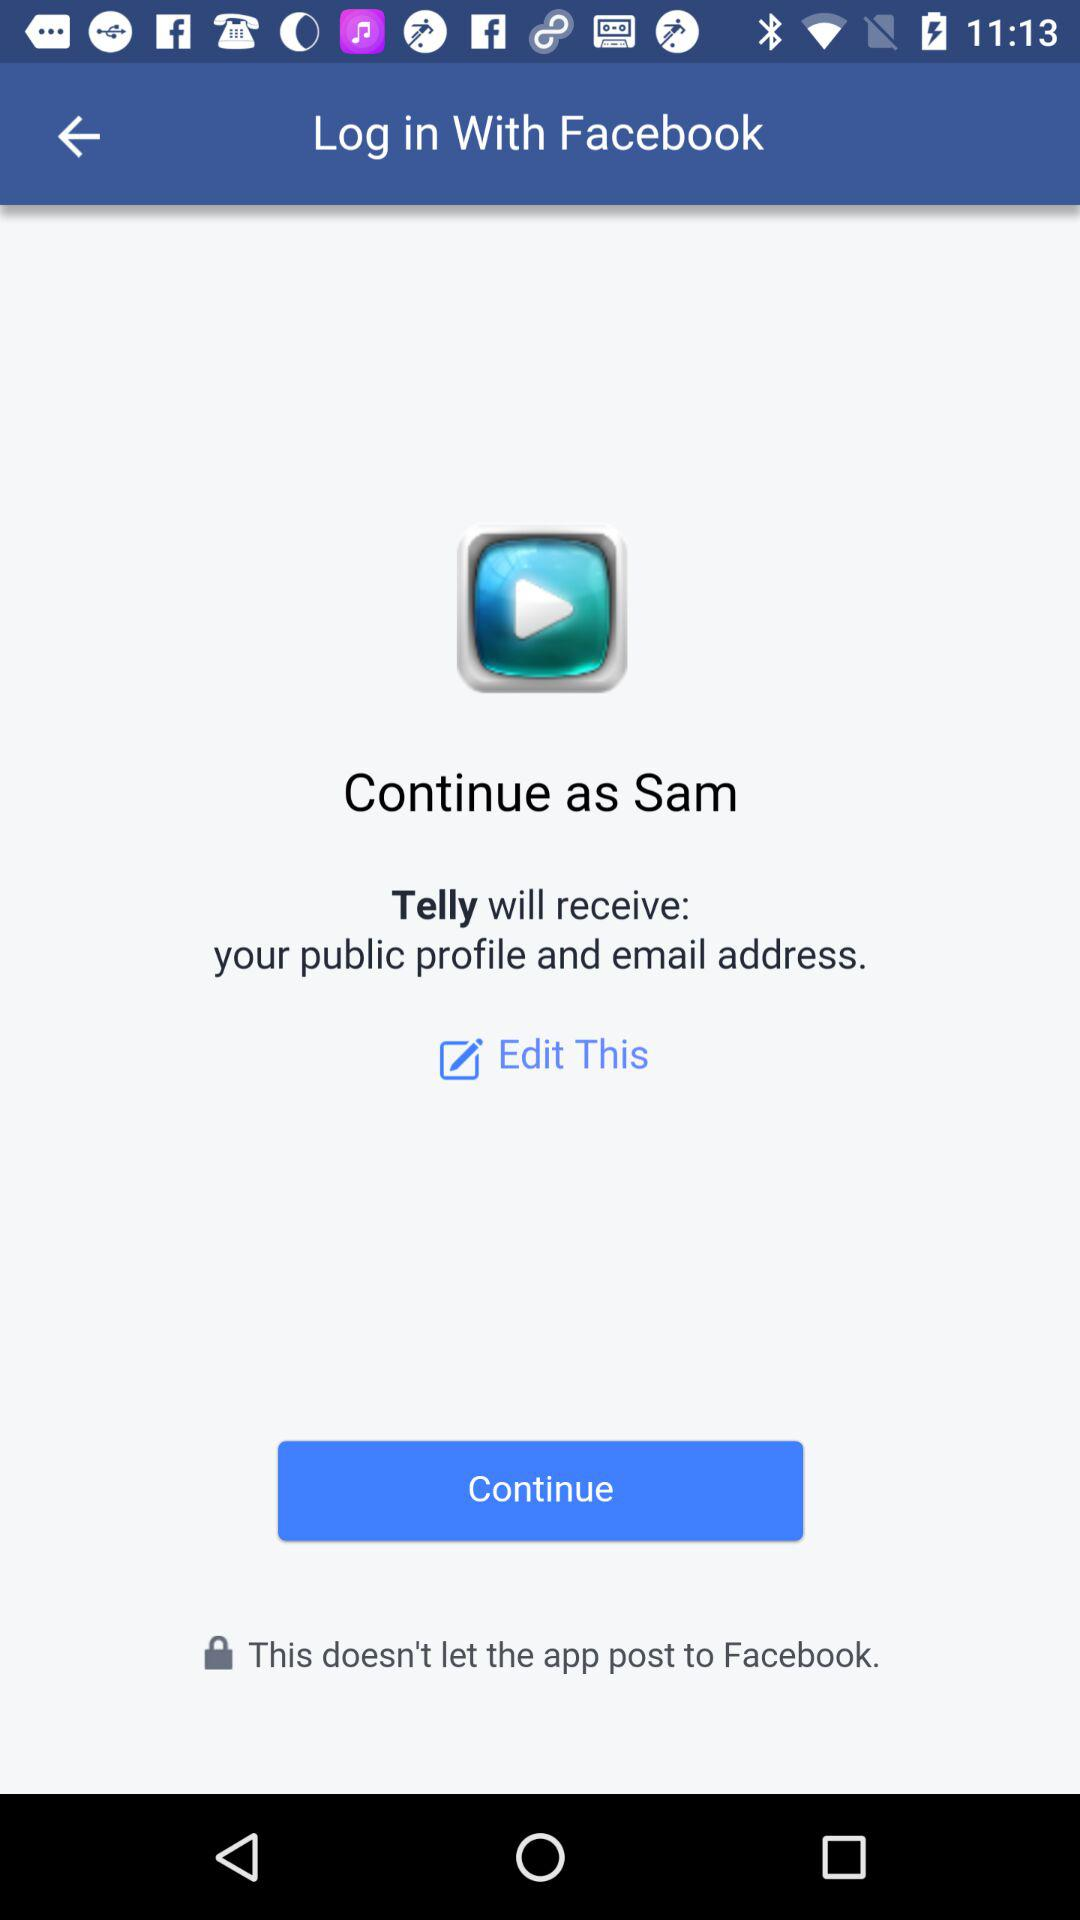Who will receive the public profile and email address? The application "Telly" will receive the public profile and email address. 